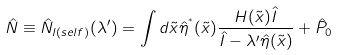Convert formula to latex. <formula><loc_0><loc_0><loc_500><loc_500>\hat { N } \equiv \hat { N } _ { l ( s e l f ) } ( \lambda ^ { \prime } ) = \int d \tilde { x } \hat { \eta } ^ { ^ { * } } ( \tilde { x } ) \frac { H ( \tilde { x } ) \hat { I } } { \hat { I } - \lambda ^ { \prime } \hat { \eta } ( \tilde { x } ) } + \hat { P } _ { 0 }</formula> 